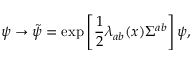<formula> <loc_0><loc_0><loc_500><loc_500>\psi \to \tilde { \psi } = \exp \left [ \frac { 1 } { 2 } \lambda _ { a b } ( x ) \Sigma ^ { a b } \right ] \psi ,</formula> 